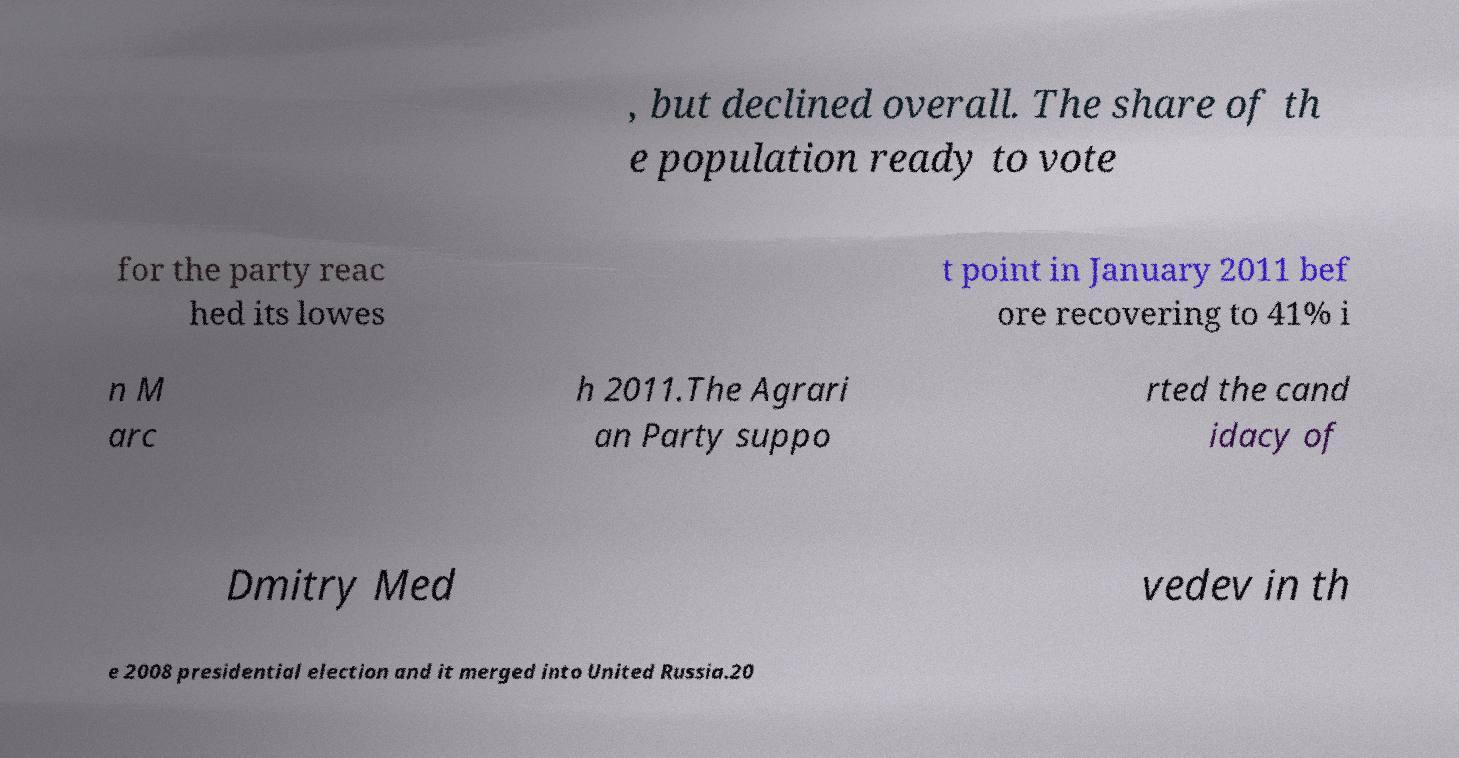Can you accurately transcribe the text from the provided image for me? , but declined overall. The share of th e population ready to vote for the party reac hed its lowes t point in January 2011 bef ore recovering to 41% i n M arc h 2011.The Agrari an Party suppo rted the cand idacy of Dmitry Med vedev in th e 2008 presidential election and it merged into United Russia.20 